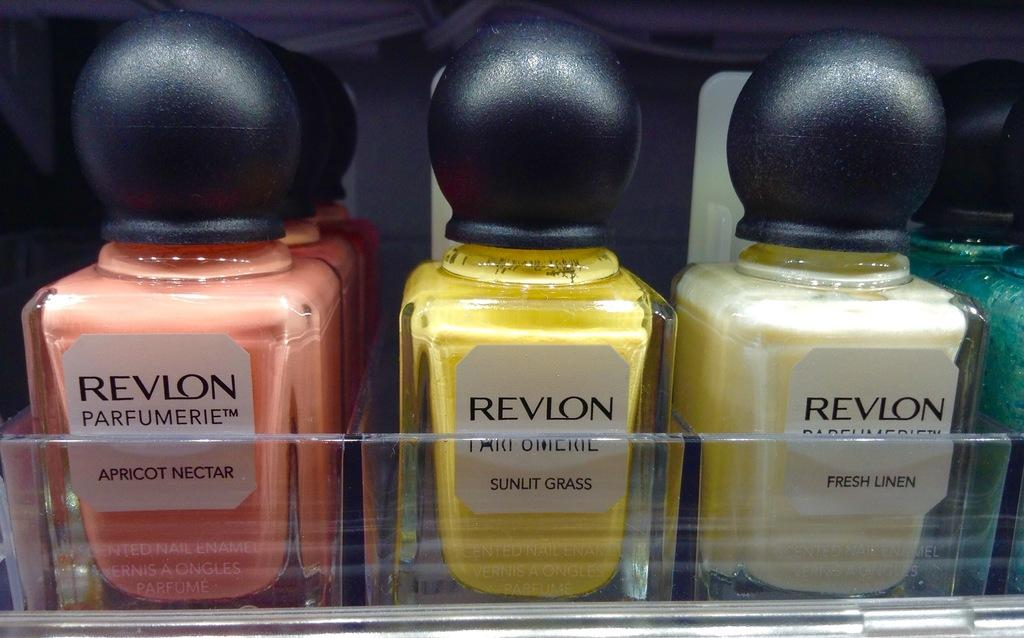<image>
Render a clear and concise summary of the photo. A number of different Revlon fragrances are displayed on a shelf. 